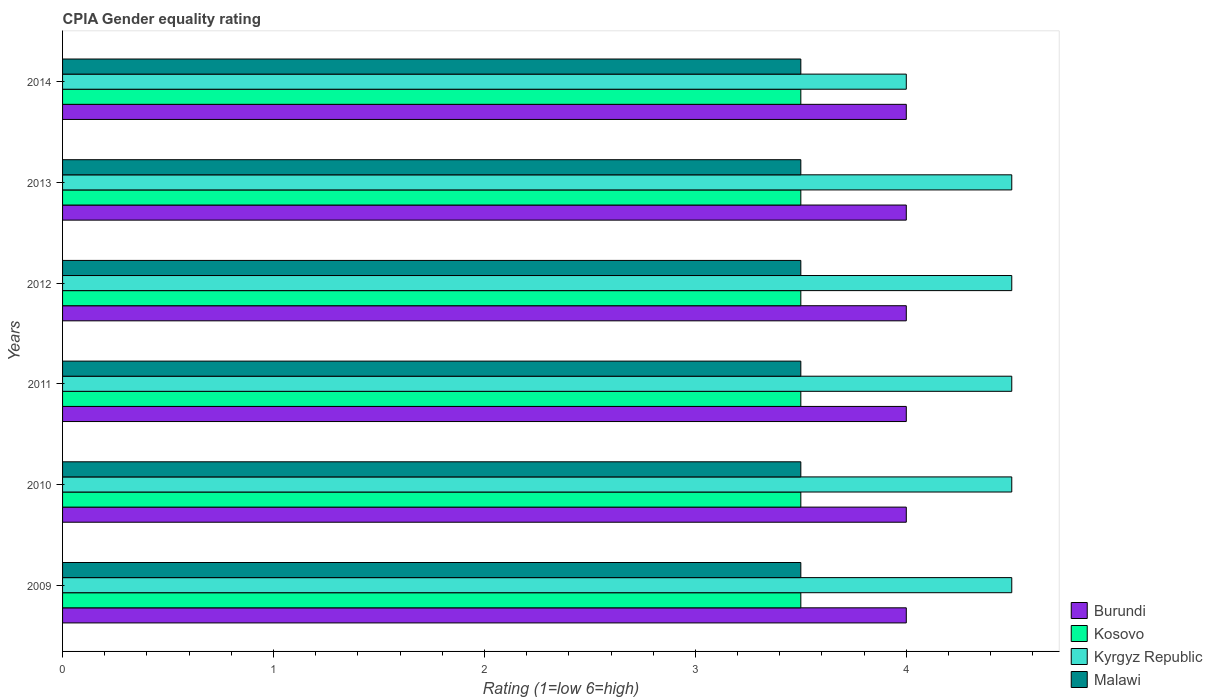How many different coloured bars are there?
Ensure brevity in your answer.  4. How many groups of bars are there?
Your answer should be very brief. 6. Are the number of bars per tick equal to the number of legend labels?
Your response must be concise. Yes. Are the number of bars on each tick of the Y-axis equal?
Ensure brevity in your answer.  Yes. Across all years, what is the maximum CPIA rating in Kosovo?
Offer a very short reply. 3.5. In which year was the CPIA rating in Malawi minimum?
Your response must be concise. 2009. What is the total CPIA rating in Kosovo in the graph?
Provide a succinct answer. 21. What is the difference between the CPIA rating in Malawi in 2010 and the CPIA rating in Burundi in 2012?
Provide a short and direct response. -0.5. What is the average CPIA rating in Burundi per year?
Give a very brief answer. 4. In how many years, is the CPIA rating in Kyrgyz Republic greater than 0.2 ?
Your answer should be very brief. 6. What is the ratio of the CPIA rating in Kyrgyz Republic in 2010 to that in 2012?
Offer a very short reply. 1. What does the 2nd bar from the top in 2014 represents?
Ensure brevity in your answer.  Kyrgyz Republic. What does the 2nd bar from the bottom in 2011 represents?
Your response must be concise. Kosovo. Is it the case that in every year, the sum of the CPIA rating in Burundi and CPIA rating in Kosovo is greater than the CPIA rating in Kyrgyz Republic?
Your answer should be very brief. Yes. Are all the bars in the graph horizontal?
Ensure brevity in your answer.  Yes. Are the values on the major ticks of X-axis written in scientific E-notation?
Your response must be concise. No. Does the graph contain any zero values?
Keep it short and to the point. No. Does the graph contain grids?
Your answer should be compact. No. Where does the legend appear in the graph?
Give a very brief answer. Bottom right. How many legend labels are there?
Your answer should be very brief. 4. How are the legend labels stacked?
Provide a short and direct response. Vertical. What is the title of the graph?
Provide a succinct answer. CPIA Gender equality rating. Does "Turkmenistan" appear as one of the legend labels in the graph?
Your response must be concise. No. What is the label or title of the X-axis?
Keep it short and to the point. Rating (1=low 6=high). What is the label or title of the Y-axis?
Provide a succinct answer. Years. What is the Rating (1=low 6=high) in Burundi in 2009?
Your answer should be very brief. 4. What is the Rating (1=low 6=high) in Kosovo in 2009?
Offer a very short reply. 3.5. What is the Rating (1=low 6=high) of Burundi in 2010?
Ensure brevity in your answer.  4. What is the Rating (1=low 6=high) in Kosovo in 2010?
Your response must be concise. 3.5. What is the Rating (1=low 6=high) in Malawi in 2010?
Give a very brief answer. 3.5. What is the Rating (1=low 6=high) in Burundi in 2011?
Your answer should be compact. 4. What is the Rating (1=low 6=high) of Kyrgyz Republic in 2011?
Provide a short and direct response. 4.5. What is the Rating (1=low 6=high) of Malawi in 2011?
Provide a short and direct response. 3.5. What is the Rating (1=low 6=high) of Burundi in 2012?
Your answer should be compact. 4. What is the Rating (1=low 6=high) in Kyrgyz Republic in 2012?
Provide a succinct answer. 4.5. What is the Rating (1=low 6=high) in Malawi in 2012?
Ensure brevity in your answer.  3.5. What is the Rating (1=low 6=high) in Kosovo in 2013?
Offer a very short reply. 3.5. What is the Rating (1=low 6=high) of Kyrgyz Republic in 2013?
Your answer should be compact. 4.5. What is the Rating (1=low 6=high) in Burundi in 2014?
Your answer should be compact. 4. What is the Rating (1=low 6=high) in Kosovo in 2014?
Offer a very short reply. 3.5. What is the Rating (1=low 6=high) in Malawi in 2014?
Give a very brief answer. 3.5. Across all years, what is the maximum Rating (1=low 6=high) in Burundi?
Ensure brevity in your answer.  4. Across all years, what is the maximum Rating (1=low 6=high) in Kyrgyz Republic?
Offer a very short reply. 4.5. Across all years, what is the maximum Rating (1=low 6=high) in Malawi?
Keep it short and to the point. 3.5. Across all years, what is the minimum Rating (1=low 6=high) in Kyrgyz Republic?
Your answer should be very brief. 4. Across all years, what is the minimum Rating (1=low 6=high) of Malawi?
Give a very brief answer. 3.5. What is the difference between the Rating (1=low 6=high) of Burundi in 2009 and that in 2010?
Ensure brevity in your answer.  0. What is the difference between the Rating (1=low 6=high) of Kosovo in 2009 and that in 2010?
Keep it short and to the point. 0. What is the difference between the Rating (1=low 6=high) of Burundi in 2009 and that in 2011?
Give a very brief answer. 0. What is the difference between the Rating (1=low 6=high) in Kyrgyz Republic in 2009 and that in 2011?
Provide a succinct answer. 0. What is the difference between the Rating (1=low 6=high) in Malawi in 2009 and that in 2011?
Provide a short and direct response. 0. What is the difference between the Rating (1=low 6=high) in Kyrgyz Republic in 2009 and that in 2012?
Your response must be concise. 0. What is the difference between the Rating (1=low 6=high) in Burundi in 2009 and that in 2013?
Offer a terse response. 0. What is the difference between the Rating (1=low 6=high) in Kyrgyz Republic in 2009 and that in 2013?
Make the answer very short. 0. What is the difference between the Rating (1=low 6=high) in Kosovo in 2010 and that in 2011?
Your response must be concise. 0. What is the difference between the Rating (1=low 6=high) in Malawi in 2010 and that in 2011?
Ensure brevity in your answer.  0. What is the difference between the Rating (1=low 6=high) of Burundi in 2010 and that in 2012?
Give a very brief answer. 0. What is the difference between the Rating (1=low 6=high) in Kyrgyz Republic in 2010 and that in 2012?
Ensure brevity in your answer.  0. What is the difference between the Rating (1=low 6=high) of Kyrgyz Republic in 2010 and that in 2013?
Give a very brief answer. 0. What is the difference between the Rating (1=low 6=high) in Malawi in 2010 and that in 2013?
Your answer should be compact. 0. What is the difference between the Rating (1=low 6=high) of Burundi in 2010 and that in 2014?
Your answer should be compact. 0. What is the difference between the Rating (1=low 6=high) of Kosovo in 2010 and that in 2014?
Keep it short and to the point. 0. What is the difference between the Rating (1=low 6=high) of Kyrgyz Republic in 2010 and that in 2014?
Ensure brevity in your answer.  0.5. What is the difference between the Rating (1=low 6=high) in Malawi in 2010 and that in 2014?
Offer a terse response. 0. What is the difference between the Rating (1=low 6=high) of Burundi in 2011 and that in 2012?
Give a very brief answer. 0. What is the difference between the Rating (1=low 6=high) of Kyrgyz Republic in 2011 and that in 2012?
Provide a succinct answer. 0. What is the difference between the Rating (1=low 6=high) of Malawi in 2011 and that in 2013?
Your answer should be very brief. 0. What is the difference between the Rating (1=low 6=high) in Kosovo in 2011 and that in 2014?
Offer a terse response. 0. What is the difference between the Rating (1=low 6=high) in Kyrgyz Republic in 2011 and that in 2014?
Give a very brief answer. 0.5. What is the difference between the Rating (1=low 6=high) in Malawi in 2011 and that in 2014?
Give a very brief answer. 0. What is the difference between the Rating (1=low 6=high) in Burundi in 2012 and that in 2013?
Your answer should be very brief. 0. What is the difference between the Rating (1=low 6=high) in Kosovo in 2012 and that in 2013?
Make the answer very short. 0. What is the difference between the Rating (1=low 6=high) of Malawi in 2012 and that in 2013?
Ensure brevity in your answer.  0. What is the difference between the Rating (1=low 6=high) of Kosovo in 2012 and that in 2014?
Ensure brevity in your answer.  0. What is the difference between the Rating (1=low 6=high) in Malawi in 2012 and that in 2014?
Provide a succinct answer. 0. What is the difference between the Rating (1=low 6=high) in Burundi in 2009 and the Rating (1=low 6=high) in Kosovo in 2010?
Give a very brief answer. 0.5. What is the difference between the Rating (1=low 6=high) in Burundi in 2009 and the Rating (1=low 6=high) in Kyrgyz Republic in 2010?
Offer a very short reply. -0.5. What is the difference between the Rating (1=low 6=high) of Kosovo in 2009 and the Rating (1=low 6=high) of Kyrgyz Republic in 2010?
Offer a terse response. -1. What is the difference between the Rating (1=low 6=high) of Kosovo in 2009 and the Rating (1=low 6=high) of Malawi in 2010?
Provide a short and direct response. 0. What is the difference between the Rating (1=low 6=high) in Burundi in 2009 and the Rating (1=low 6=high) in Malawi in 2011?
Give a very brief answer. 0.5. What is the difference between the Rating (1=low 6=high) in Kosovo in 2009 and the Rating (1=low 6=high) in Kyrgyz Republic in 2011?
Give a very brief answer. -1. What is the difference between the Rating (1=low 6=high) of Kosovo in 2009 and the Rating (1=low 6=high) of Malawi in 2011?
Your response must be concise. 0. What is the difference between the Rating (1=low 6=high) in Kyrgyz Republic in 2009 and the Rating (1=low 6=high) in Malawi in 2011?
Ensure brevity in your answer.  1. What is the difference between the Rating (1=low 6=high) in Kosovo in 2009 and the Rating (1=low 6=high) in Kyrgyz Republic in 2012?
Ensure brevity in your answer.  -1. What is the difference between the Rating (1=low 6=high) of Kosovo in 2009 and the Rating (1=low 6=high) of Malawi in 2012?
Ensure brevity in your answer.  0. What is the difference between the Rating (1=low 6=high) in Kyrgyz Republic in 2009 and the Rating (1=low 6=high) in Malawi in 2012?
Your answer should be very brief. 1. What is the difference between the Rating (1=low 6=high) in Burundi in 2009 and the Rating (1=low 6=high) in Kosovo in 2013?
Provide a succinct answer. 0.5. What is the difference between the Rating (1=low 6=high) in Kyrgyz Republic in 2009 and the Rating (1=low 6=high) in Malawi in 2013?
Offer a very short reply. 1. What is the difference between the Rating (1=low 6=high) of Burundi in 2009 and the Rating (1=low 6=high) of Malawi in 2014?
Provide a succinct answer. 0.5. What is the difference between the Rating (1=low 6=high) of Kosovo in 2009 and the Rating (1=low 6=high) of Kyrgyz Republic in 2014?
Provide a succinct answer. -0.5. What is the difference between the Rating (1=low 6=high) of Kosovo in 2009 and the Rating (1=low 6=high) of Malawi in 2014?
Provide a succinct answer. 0. What is the difference between the Rating (1=low 6=high) of Burundi in 2010 and the Rating (1=low 6=high) of Kosovo in 2011?
Offer a terse response. 0.5. What is the difference between the Rating (1=low 6=high) of Burundi in 2010 and the Rating (1=low 6=high) of Malawi in 2011?
Provide a succinct answer. 0.5. What is the difference between the Rating (1=low 6=high) of Kosovo in 2010 and the Rating (1=low 6=high) of Kyrgyz Republic in 2011?
Keep it short and to the point. -1. What is the difference between the Rating (1=low 6=high) of Kyrgyz Republic in 2010 and the Rating (1=low 6=high) of Malawi in 2011?
Provide a short and direct response. 1. What is the difference between the Rating (1=low 6=high) in Burundi in 2010 and the Rating (1=low 6=high) in Kosovo in 2012?
Your answer should be compact. 0.5. What is the difference between the Rating (1=low 6=high) of Burundi in 2010 and the Rating (1=low 6=high) of Kyrgyz Republic in 2012?
Offer a very short reply. -0.5. What is the difference between the Rating (1=low 6=high) of Kosovo in 2010 and the Rating (1=low 6=high) of Malawi in 2012?
Provide a short and direct response. 0. What is the difference between the Rating (1=low 6=high) of Burundi in 2010 and the Rating (1=low 6=high) of Malawi in 2013?
Ensure brevity in your answer.  0.5. What is the difference between the Rating (1=low 6=high) of Kosovo in 2010 and the Rating (1=low 6=high) of Malawi in 2013?
Make the answer very short. 0. What is the difference between the Rating (1=low 6=high) of Kyrgyz Republic in 2010 and the Rating (1=low 6=high) of Malawi in 2013?
Provide a succinct answer. 1. What is the difference between the Rating (1=low 6=high) of Burundi in 2010 and the Rating (1=low 6=high) of Kyrgyz Republic in 2014?
Provide a short and direct response. 0. What is the difference between the Rating (1=low 6=high) in Kosovo in 2010 and the Rating (1=low 6=high) in Malawi in 2014?
Provide a succinct answer. 0. What is the difference between the Rating (1=low 6=high) of Burundi in 2011 and the Rating (1=low 6=high) of Kosovo in 2012?
Offer a very short reply. 0.5. What is the difference between the Rating (1=low 6=high) in Burundi in 2011 and the Rating (1=low 6=high) in Malawi in 2012?
Your answer should be compact. 0.5. What is the difference between the Rating (1=low 6=high) of Kyrgyz Republic in 2011 and the Rating (1=low 6=high) of Malawi in 2012?
Provide a succinct answer. 1. What is the difference between the Rating (1=low 6=high) of Burundi in 2011 and the Rating (1=low 6=high) of Kyrgyz Republic in 2013?
Offer a terse response. -0.5. What is the difference between the Rating (1=low 6=high) in Kosovo in 2011 and the Rating (1=low 6=high) in Kyrgyz Republic in 2013?
Provide a succinct answer. -1. What is the difference between the Rating (1=low 6=high) in Kosovo in 2011 and the Rating (1=low 6=high) in Malawi in 2013?
Give a very brief answer. 0. What is the difference between the Rating (1=low 6=high) in Kyrgyz Republic in 2011 and the Rating (1=low 6=high) in Malawi in 2013?
Your response must be concise. 1. What is the difference between the Rating (1=low 6=high) in Burundi in 2011 and the Rating (1=low 6=high) in Kyrgyz Republic in 2014?
Keep it short and to the point. 0. What is the difference between the Rating (1=low 6=high) in Burundi in 2011 and the Rating (1=low 6=high) in Malawi in 2014?
Offer a very short reply. 0.5. What is the difference between the Rating (1=low 6=high) in Kosovo in 2011 and the Rating (1=low 6=high) in Malawi in 2014?
Offer a terse response. 0. What is the difference between the Rating (1=low 6=high) in Kyrgyz Republic in 2011 and the Rating (1=low 6=high) in Malawi in 2014?
Your response must be concise. 1. What is the difference between the Rating (1=low 6=high) of Burundi in 2012 and the Rating (1=low 6=high) of Kosovo in 2013?
Give a very brief answer. 0.5. What is the difference between the Rating (1=low 6=high) in Burundi in 2012 and the Rating (1=low 6=high) in Malawi in 2013?
Your answer should be very brief. 0.5. What is the difference between the Rating (1=low 6=high) in Kosovo in 2012 and the Rating (1=low 6=high) in Malawi in 2013?
Your answer should be compact. 0. What is the difference between the Rating (1=low 6=high) in Kyrgyz Republic in 2012 and the Rating (1=low 6=high) in Malawi in 2013?
Provide a succinct answer. 1. What is the difference between the Rating (1=low 6=high) of Burundi in 2012 and the Rating (1=low 6=high) of Kosovo in 2014?
Keep it short and to the point. 0.5. What is the difference between the Rating (1=low 6=high) in Burundi in 2012 and the Rating (1=low 6=high) in Kyrgyz Republic in 2014?
Your response must be concise. 0. What is the difference between the Rating (1=low 6=high) in Burundi in 2012 and the Rating (1=low 6=high) in Malawi in 2014?
Keep it short and to the point. 0.5. What is the difference between the Rating (1=low 6=high) of Kosovo in 2012 and the Rating (1=low 6=high) of Malawi in 2014?
Give a very brief answer. 0. What is the difference between the Rating (1=low 6=high) in Kyrgyz Republic in 2012 and the Rating (1=low 6=high) in Malawi in 2014?
Provide a short and direct response. 1. What is the difference between the Rating (1=low 6=high) of Burundi in 2013 and the Rating (1=low 6=high) of Kyrgyz Republic in 2014?
Ensure brevity in your answer.  0. What is the difference between the Rating (1=low 6=high) of Burundi in 2013 and the Rating (1=low 6=high) of Malawi in 2014?
Provide a succinct answer. 0.5. What is the difference between the Rating (1=low 6=high) of Kosovo in 2013 and the Rating (1=low 6=high) of Kyrgyz Republic in 2014?
Your response must be concise. -0.5. What is the difference between the Rating (1=low 6=high) of Kyrgyz Republic in 2013 and the Rating (1=low 6=high) of Malawi in 2014?
Give a very brief answer. 1. What is the average Rating (1=low 6=high) of Kosovo per year?
Offer a very short reply. 3.5. What is the average Rating (1=low 6=high) of Kyrgyz Republic per year?
Provide a succinct answer. 4.42. In the year 2009, what is the difference between the Rating (1=low 6=high) in Burundi and Rating (1=low 6=high) in Kosovo?
Provide a short and direct response. 0.5. In the year 2010, what is the difference between the Rating (1=low 6=high) of Burundi and Rating (1=low 6=high) of Kosovo?
Offer a terse response. 0.5. In the year 2010, what is the difference between the Rating (1=low 6=high) in Burundi and Rating (1=low 6=high) in Kyrgyz Republic?
Make the answer very short. -0.5. In the year 2010, what is the difference between the Rating (1=low 6=high) in Burundi and Rating (1=low 6=high) in Malawi?
Your answer should be very brief. 0.5. In the year 2010, what is the difference between the Rating (1=low 6=high) of Kosovo and Rating (1=low 6=high) of Kyrgyz Republic?
Offer a very short reply. -1. In the year 2010, what is the difference between the Rating (1=low 6=high) of Kosovo and Rating (1=low 6=high) of Malawi?
Make the answer very short. 0. In the year 2010, what is the difference between the Rating (1=low 6=high) in Kyrgyz Republic and Rating (1=low 6=high) in Malawi?
Make the answer very short. 1. In the year 2011, what is the difference between the Rating (1=low 6=high) in Burundi and Rating (1=low 6=high) in Kosovo?
Keep it short and to the point. 0.5. In the year 2012, what is the difference between the Rating (1=low 6=high) of Burundi and Rating (1=low 6=high) of Kosovo?
Make the answer very short. 0.5. In the year 2012, what is the difference between the Rating (1=low 6=high) in Burundi and Rating (1=low 6=high) in Kyrgyz Republic?
Offer a terse response. -0.5. In the year 2012, what is the difference between the Rating (1=low 6=high) of Burundi and Rating (1=low 6=high) of Malawi?
Your response must be concise. 0.5. In the year 2012, what is the difference between the Rating (1=low 6=high) of Kosovo and Rating (1=low 6=high) of Kyrgyz Republic?
Your answer should be very brief. -1. In the year 2012, what is the difference between the Rating (1=low 6=high) in Kosovo and Rating (1=low 6=high) in Malawi?
Keep it short and to the point. 0. In the year 2012, what is the difference between the Rating (1=low 6=high) in Kyrgyz Republic and Rating (1=low 6=high) in Malawi?
Provide a succinct answer. 1. In the year 2013, what is the difference between the Rating (1=low 6=high) of Burundi and Rating (1=low 6=high) of Kosovo?
Your answer should be very brief. 0.5. In the year 2013, what is the difference between the Rating (1=low 6=high) of Burundi and Rating (1=low 6=high) of Kyrgyz Republic?
Offer a very short reply. -0.5. In the year 2013, what is the difference between the Rating (1=low 6=high) in Kosovo and Rating (1=low 6=high) in Kyrgyz Republic?
Provide a short and direct response. -1. In the year 2013, what is the difference between the Rating (1=low 6=high) of Kyrgyz Republic and Rating (1=low 6=high) of Malawi?
Keep it short and to the point. 1. In the year 2014, what is the difference between the Rating (1=low 6=high) of Burundi and Rating (1=low 6=high) of Malawi?
Ensure brevity in your answer.  0.5. In the year 2014, what is the difference between the Rating (1=low 6=high) of Kosovo and Rating (1=low 6=high) of Kyrgyz Republic?
Provide a succinct answer. -0.5. In the year 2014, what is the difference between the Rating (1=low 6=high) in Kosovo and Rating (1=low 6=high) in Malawi?
Your answer should be very brief. 0. What is the ratio of the Rating (1=low 6=high) in Burundi in 2009 to that in 2010?
Make the answer very short. 1. What is the ratio of the Rating (1=low 6=high) of Malawi in 2009 to that in 2010?
Your response must be concise. 1. What is the ratio of the Rating (1=low 6=high) in Burundi in 2009 to that in 2011?
Ensure brevity in your answer.  1. What is the ratio of the Rating (1=low 6=high) of Kyrgyz Republic in 2009 to that in 2011?
Offer a very short reply. 1. What is the ratio of the Rating (1=low 6=high) of Malawi in 2009 to that in 2011?
Offer a terse response. 1. What is the ratio of the Rating (1=low 6=high) in Burundi in 2009 to that in 2012?
Your response must be concise. 1. What is the ratio of the Rating (1=low 6=high) in Malawi in 2009 to that in 2012?
Offer a very short reply. 1. What is the ratio of the Rating (1=low 6=high) of Kosovo in 2009 to that in 2013?
Provide a succinct answer. 1. What is the ratio of the Rating (1=low 6=high) of Malawi in 2009 to that in 2014?
Your response must be concise. 1. What is the ratio of the Rating (1=low 6=high) in Kosovo in 2010 to that in 2011?
Your answer should be compact. 1. What is the ratio of the Rating (1=low 6=high) in Kyrgyz Republic in 2010 to that in 2011?
Provide a succinct answer. 1. What is the ratio of the Rating (1=low 6=high) of Kosovo in 2010 to that in 2012?
Keep it short and to the point. 1. What is the ratio of the Rating (1=low 6=high) of Kyrgyz Republic in 2010 to that in 2013?
Provide a short and direct response. 1. What is the ratio of the Rating (1=low 6=high) in Malawi in 2010 to that in 2013?
Keep it short and to the point. 1. What is the ratio of the Rating (1=low 6=high) in Kosovo in 2010 to that in 2014?
Give a very brief answer. 1. What is the ratio of the Rating (1=low 6=high) of Malawi in 2010 to that in 2014?
Offer a terse response. 1. What is the ratio of the Rating (1=low 6=high) in Burundi in 2011 to that in 2013?
Your answer should be compact. 1. What is the ratio of the Rating (1=low 6=high) in Kosovo in 2011 to that in 2013?
Provide a short and direct response. 1. What is the ratio of the Rating (1=low 6=high) of Kyrgyz Republic in 2011 to that in 2013?
Make the answer very short. 1. What is the ratio of the Rating (1=low 6=high) of Burundi in 2011 to that in 2014?
Offer a terse response. 1. What is the ratio of the Rating (1=low 6=high) in Kosovo in 2011 to that in 2014?
Keep it short and to the point. 1. What is the ratio of the Rating (1=low 6=high) in Burundi in 2012 to that in 2013?
Provide a short and direct response. 1. What is the ratio of the Rating (1=low 6=high) in Kyrgyz Republic in 2012 to that in 2013?
Your answer should be compact. 1. What is the ratio of the Rating (1=low 6=high) in Burundi in 2012 to that in 2014?
Make the answer very short. 1. What is the ratio of the Rating (1=low 6=high) in Kosovo in 2013 to that in 2014?
Ensure brevity in your answer.  1. What is the difference between the highest and the second highest Rating (1=low 6=high) in Burundi?
Make the answer very short. 0. What is the difference between the highest and the second highest Rating (1=low 6=high) in Kosovo?
Keep it short and to the point. 0. What is the difference between the highest and the second highest Rating (1=low 6=high) in Malawi?
Make the answer very short. 0. 